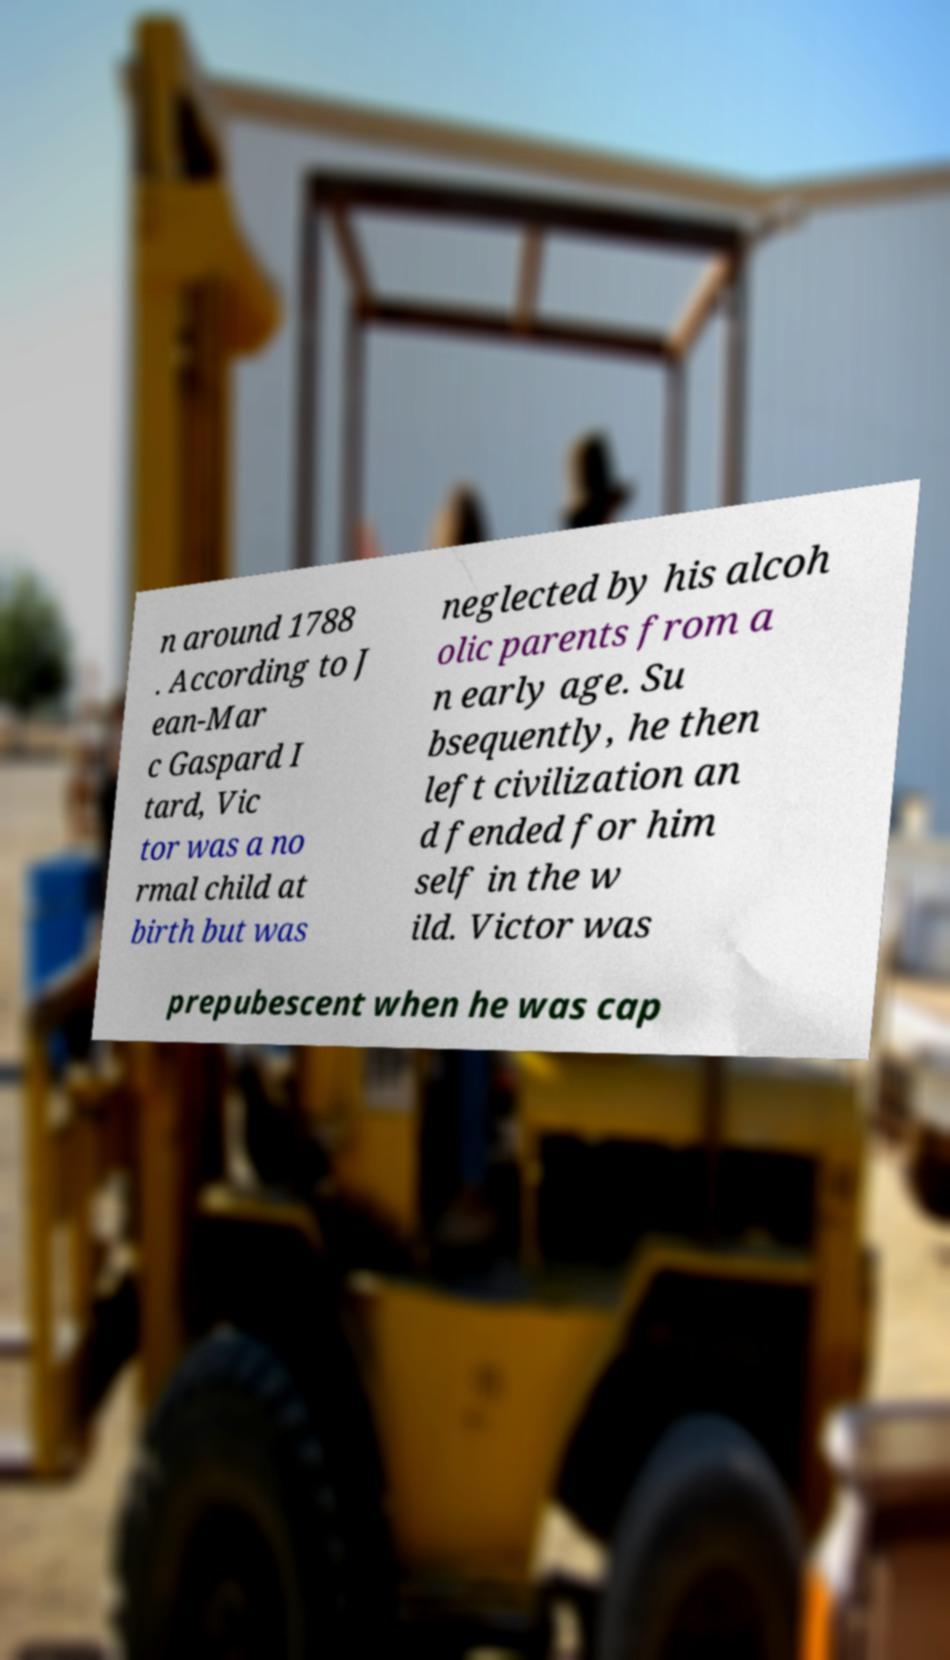Please read and relay the text visible in this image. What does it say? n around 1788 . According to J ean-Mar c Gaspard I tard, Vic tor was a no rmal child at birth but was neglected by his alcoh olic parents from a n early age. Su bsequently, he then left civilization an d fended for him self in the w ild. Victor was prepubescent when he was cap 